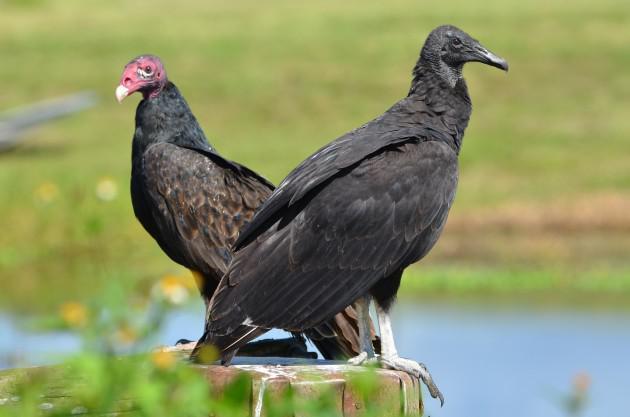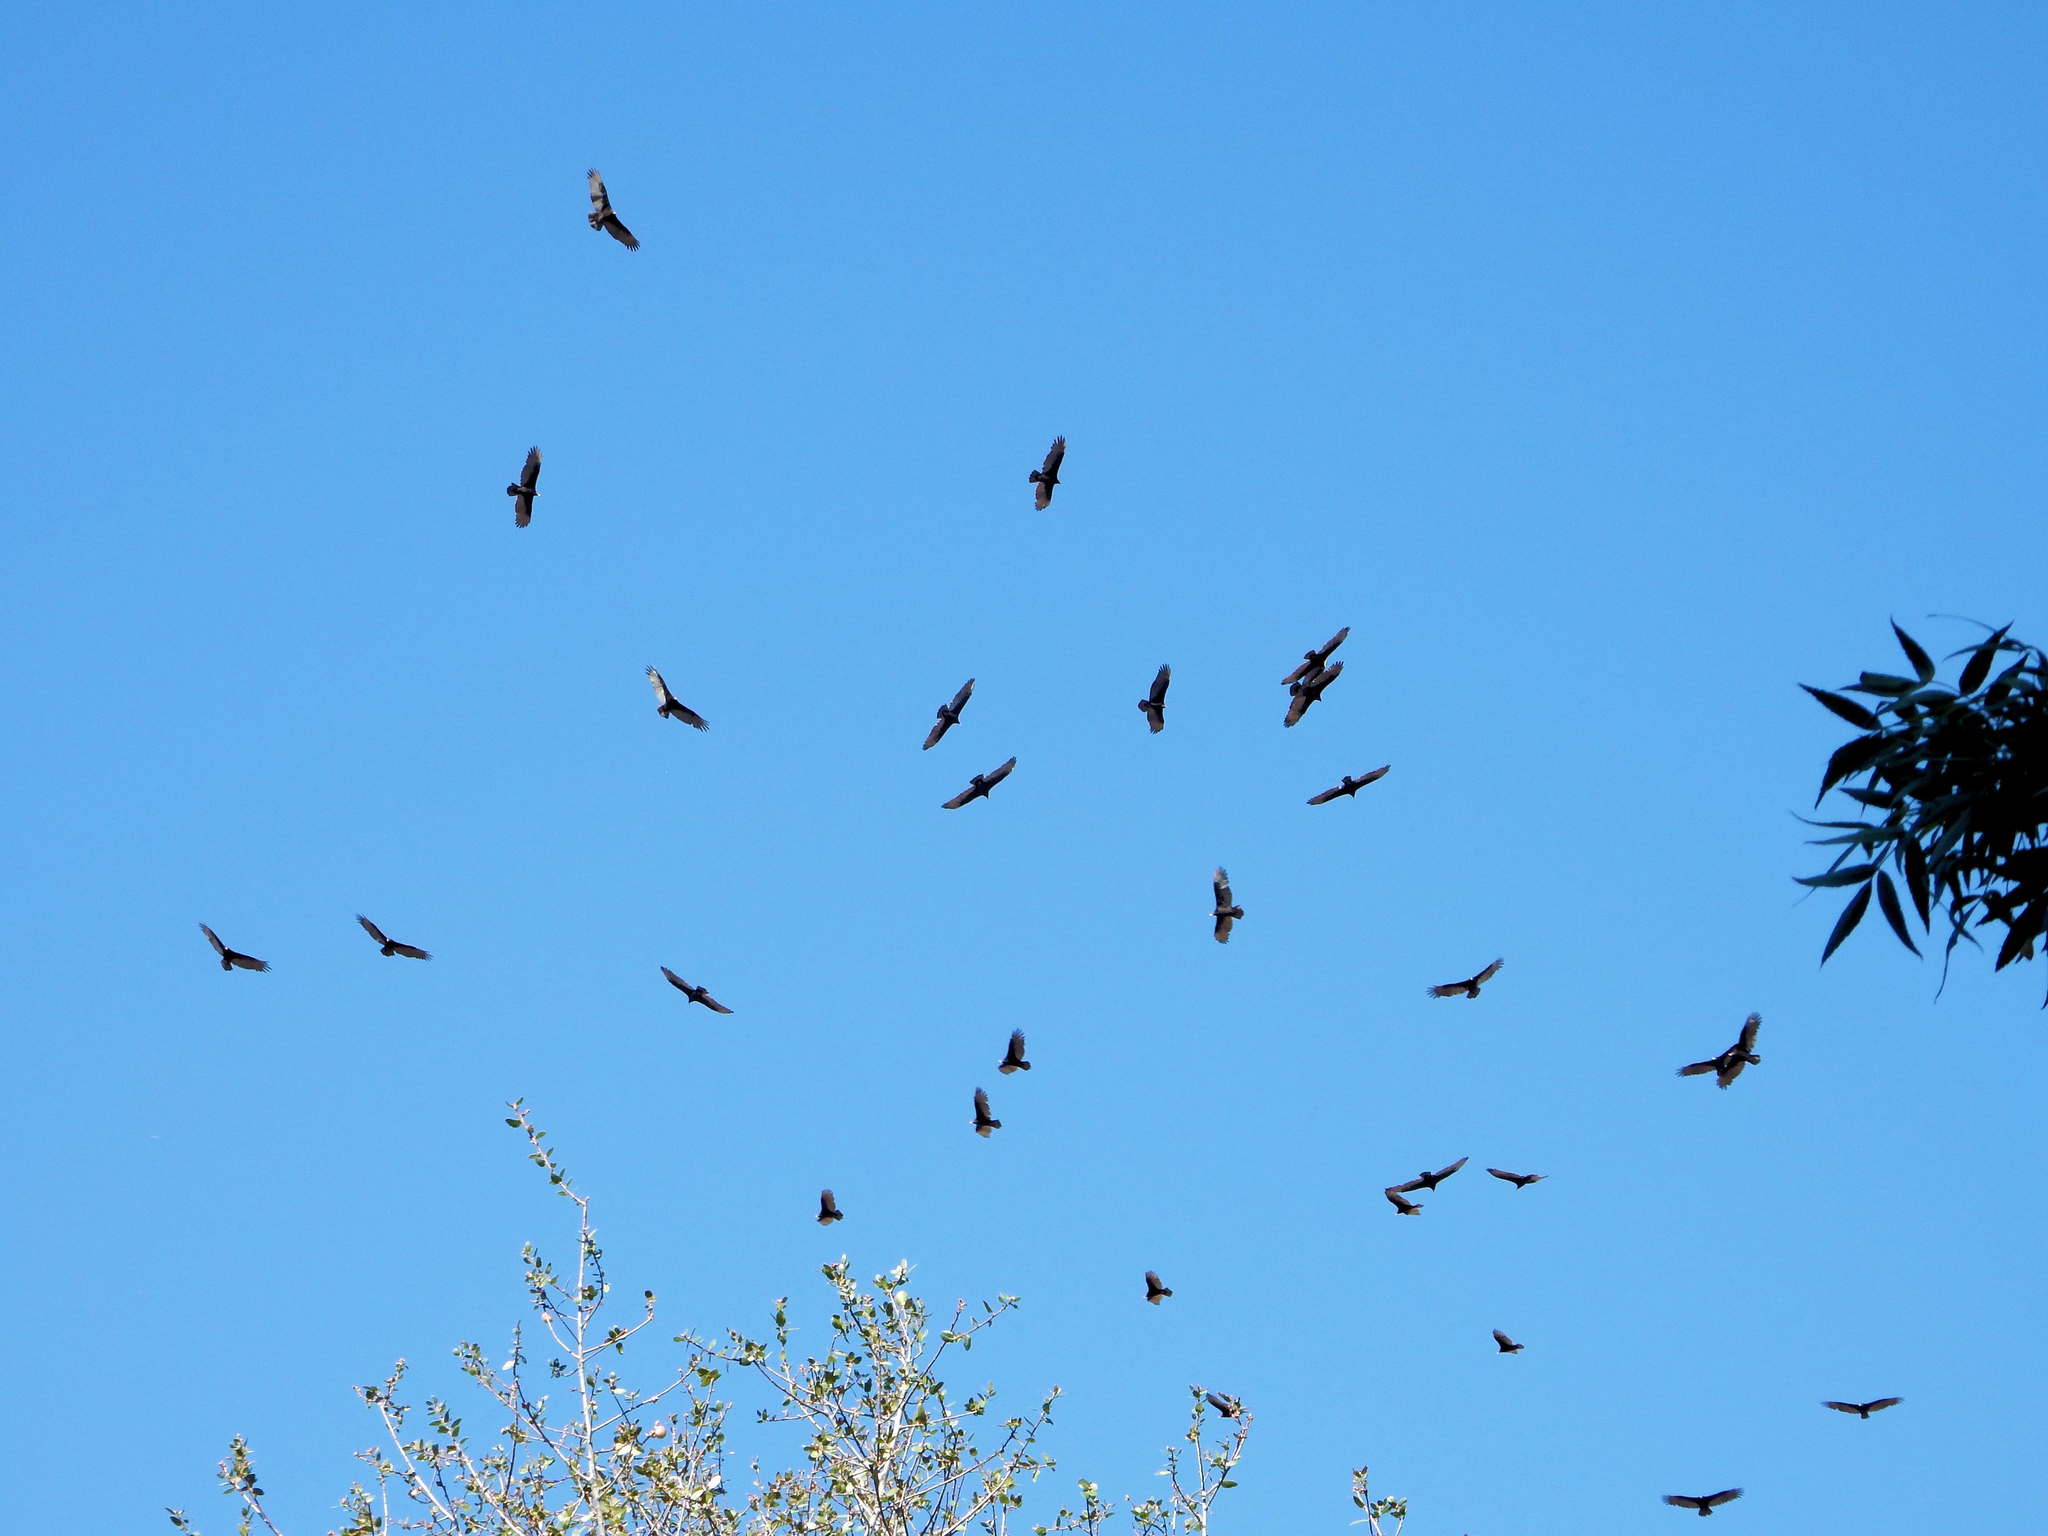The first image is the image on the left, the second image is the image on the right. Examine the images to the left and right. Is the description "The left image features one vulture with tucked wings, and the right image features one leftward-facing vulture with spread wings." accurate? Answer yes or no. No. The first image is the image on the left, the second image is the image on the right. Given the left and right images, does the statement "The left and right image contains the same number of vultures." hold true? Answer yes or no. No. 